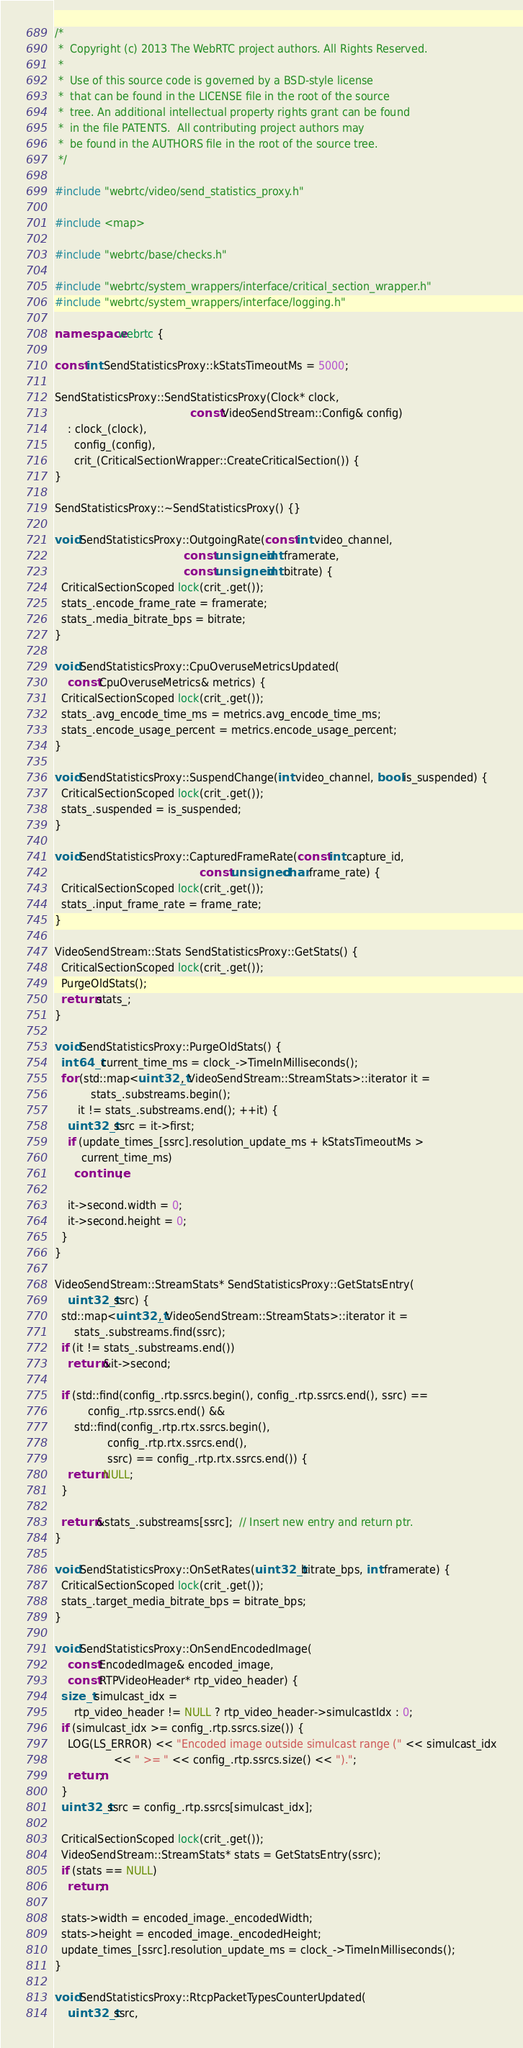Convert code to text. <code><loc_0><loc_0><loc_500><loc_500><_C++_>/*
 *  Copyright (c) 2013 The WebRTC project authors. All Rights Reserved.
 *
 *  Use of this source code is governed by a BSD-style license
 *  that can be found in the LICENSE file in the root of the source
 *  tree. An additional intellectual property rights grant can be found
 *  in the file PATENTS.  All contributing project authors may
 *  be found in the AUTHORS file in the root of the source tree.
 */

#include "webrtc/video/send_statistics_proxy.h"

#include <map>

#include "webrtc/base/checks.h"

#include "webrtc/system_wrappers/interface/critical_section_wrapper.h"
#include "webrtc/system_wrappers/interface/logging.h"

namespace webrtc {

const int SendStatisticsProxy::kStatsTimeoutMs = 5000;

SendStatisticsProxy::SendStatisticsProxy(Clock* clock,
                                         const VideoSendStream::Config& config)
    : clock_(clock),
      config_(config),
      crit_(CriticalSectionWrapper::CreateCriticalSection()) {
}

SendStatisticsProxy::~SendStatisticsProxy() {}

void SendStatisticsProxy::OutgoingRate(const int video_channel,
                                       const unsigned int framerate,
                                       const unsigned int bitrate) {
  CriticalSectionScoped lock(crit_.get());
  stats_.encode_frame_rate = framerate;
  stats_.media_bitrate_bps = bitrate;
}

void SendStatisticsProxy::CpuOveruseMetricsUpdated(
    const CpuOveruseMetrics& metrics) {
  CriticalSectionScoped lock(crit_.get());
  stats_.avg_encode_time_ms = metrics.avg_encode_time_ms;
  stats_.encode_usage_percent = metrics.encode_usage_percent;
}

void SendStatisticsProxy::SuspendChange(int video_channel, bool is_suspended) {
  CriticalSectionScoped lock(crit_.get());
  stats_.suspended = is_suspended;
}

void SendStatisticsProxy::CapturedFrameRate(const int capture_id,
                                            const unsigned char frame_rate) {
  CriticalSectionScoped lock(crit_.get());
  stats_.input_frame_rate = frame_rate;
}

VideoSendStream::Stats SendStatisticsProxy::GetStats() {
  CriticalSectionScoped lock(crit_.get());
  PurgeOldStats();
  return stats_;
}

void SendStatisticsProxy::PurgeOldStats() {
  int64_t current_time_ms = clock_->TimeInMilliseconds();
  for (std::map<uint32_t, VideoSendStream::StreamStats>::iterator it =
           stats_.substreams.begin();
       it != stats_.substreams.end(); ++it) {
    uint32_t ssrc = it->first;
    if (update_times_[ssrc].resolution_update_ms + kStatsTimeoutMs >
        current_time_ms)
      continue;

    it->second.width = 0;
    it->second.height = 0;
  }
}

VideoSendStream::StreamStats* SendStatisticsProxy::GetStatsEntry(
    uint32_t ssrc) {
  std::map<uint32_t, VideoSendStream::StreamStats>::iterator it =
      stats_.substreams.find(ssrc);
  if (it != stats_.substreams.end())
    return &it->second;

  if (std::find(config_.rtp.ssrcs.begin(), config_.rtp.ssrcs.end(), ssrc) ==
          config_.rtp.ssrcs.end() &&
      std::find(config_.rtp.rtx.ssrcs.begin(),
                config_.rtp.rtx.ssrcs.end(),
                ssrc) == config_.rtp.rtx.ssrcs.end()) {
    return NULL;
  }

  return &stats_.substreams[ssrc];  // Insert new entry and return ptr.
}

void SendStatisticsProxy::OnSetRates(uint32_t bitrate_bps, int framerate) {
  CriticalSectionScoped lock(crit_.get());
  stats_.target_media_bitrate_bps = bitrate_bps;
}

void SendStatisticsProxy::OnSendEncodedImage(
    const EncodedImage& encoded_image,
    const RTPVideoHeader* rtp_video_header) {
  size_t simulcast_idx =
      rtp_video_header != NULL ? rtp_video_header->simulcastIdx : 0;
  if (simulcast_idx >= config_.rtp.ssrcs.size()) {
    LOG(LS_ERROR) << "Encoded image outside simulcast range (" << simulcast_idx
                  << " >= " << config_.rtp.ssrcs.size() << ").";
    return;
  }
  uint32_t ssrc = config_.rtp.ssrcs[simulcast_idx];

  CriticalSectionScoped lock(crit_.get());
  VideoSendStream::StreamStats* stats = GetStatsEntry(ssrc);
  if (stats == NULL)
    return;

  stats->width = encoded_image._encodedWidth;
  stats->height = encoded_image._encodedHeight;
  update_times_[ssrc].resolution_update_ms = clock_->TimeInMilliseconds();
}

void SendStatisticsProxy::RtcpPacketTypesCounterUpdated(
    uint32_t ssrc,</code> 